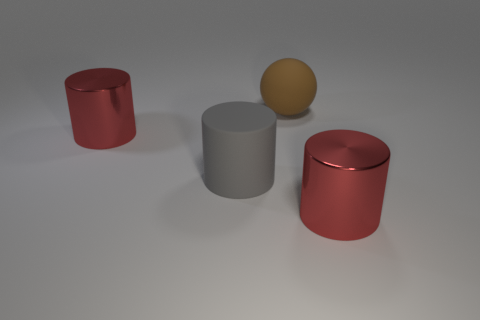Is the color of the cylinder that is on the right side of the gray matte cylinder the same as the big metallic object on the left side of the brown sphere?
Your answer should be very brief. Yes. How many other objects are there of the same shape as the big gray matte object?
Ensure brevity in your answer.  2. Do the brown ball and the gray matte cylinder have the same size?
Give a very brief answer. Yes. Are there more big things that are to the right of the sphere than small blue metallic cylinders?
Your answer should be very brief. Yes. The large rubber sphere that is on the left side of the red shiny cylinder in front of the gray cylinder is what color?
Your answer should be compact. Brown. What number of objects are either big red cylinders left of the brown sphere or red things on the right side of the large brown rubber thing?
Your answer should be compact. 2. What is the color of the large matte cylinder?
Make the answer very short. Gray. How many things have the same material as the big gray cylinder?
Your answer should be very brief. 1. Is the number of big cubes greater than the number of red objects?
Ensure brevity in your answer.  No. What number of red objects are in front of the brown thing that is right of the gray matte cylinder?
Ensure brevity in your answer.  2. 